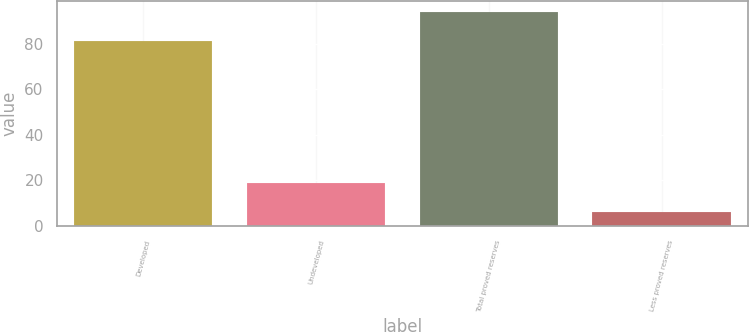Convert chart. <chart><loc_0><loc_0><loc_500><loc_500><bar_chart><fcel>Developed<fcel>Undeveloped<fcel>Total proved reserves<fcel>Less proved reserves<nl><fcel>81<fcel>19<fcel>94<fcel>6<nl></chart> 